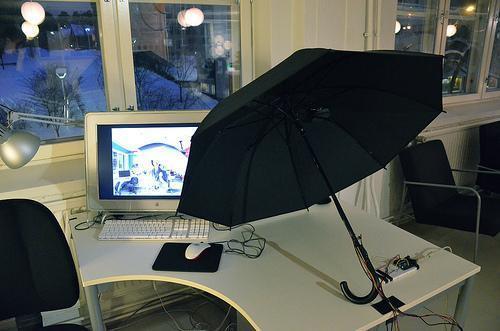How many umbrellas are in the photo?
Give a very brief answer. 1. 